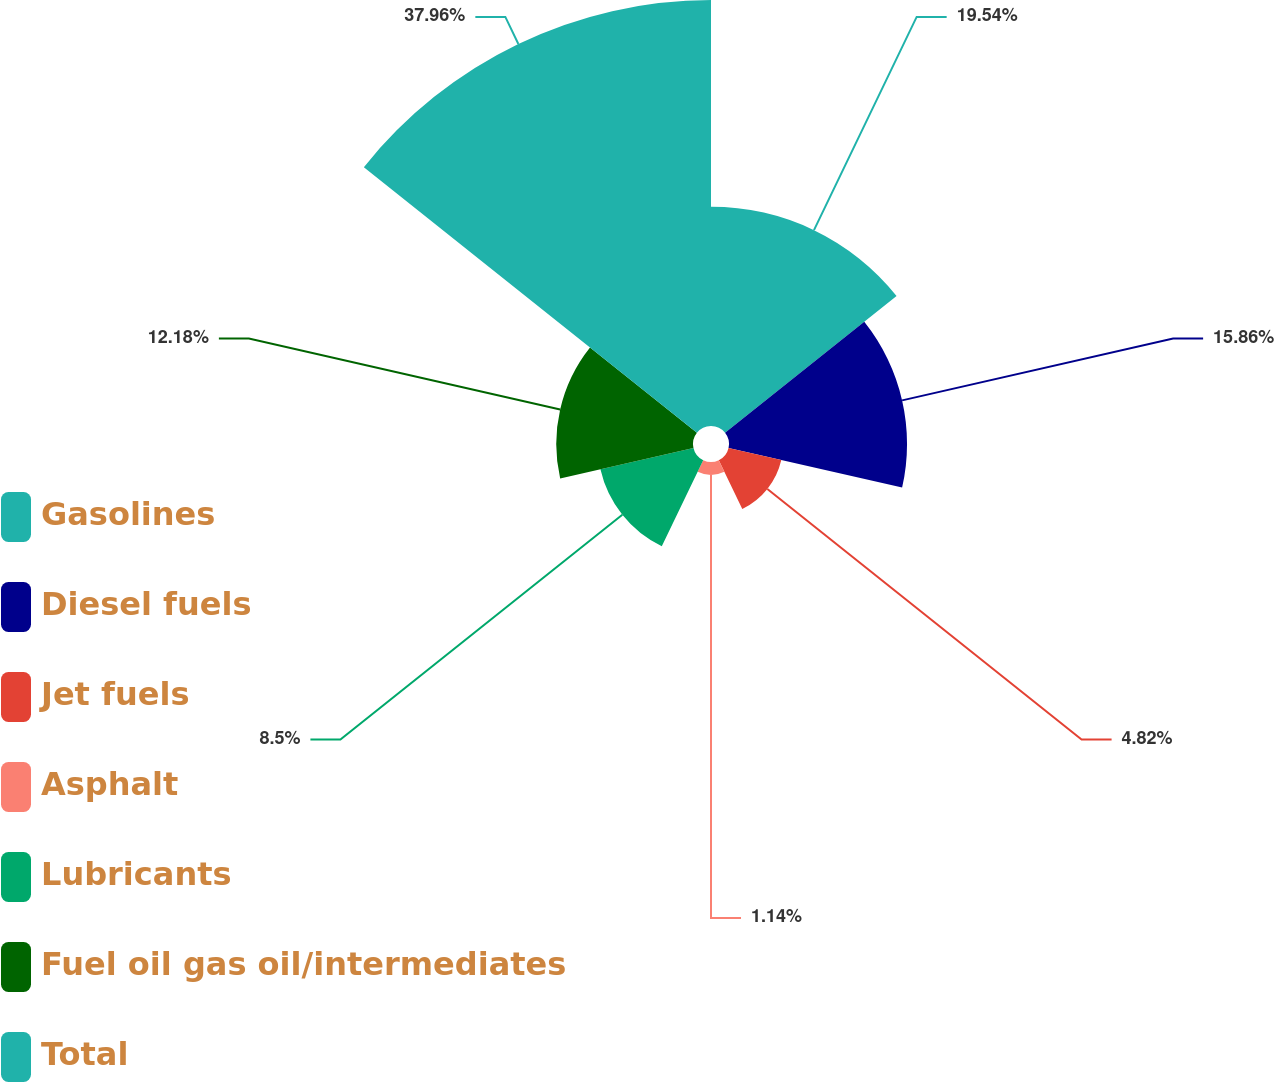Convert chart. <chart><loc_0><loc_0><loc_500><loc_500><pie_chart><fcel>Gasolines<fcel>Diesel fuels<fcel>Jet fuels<fcel>Asphalt<fcel>Lubricants<fcel>Fuel oil gas oil/intermediates<fcel>Total<nl><fcel>19.54%<fcel>15.86%<fcel>4.82%<fcel>1.14%<fcel>8.5%<fcel>12.18%<fcel>37.95%<nl></chart> 